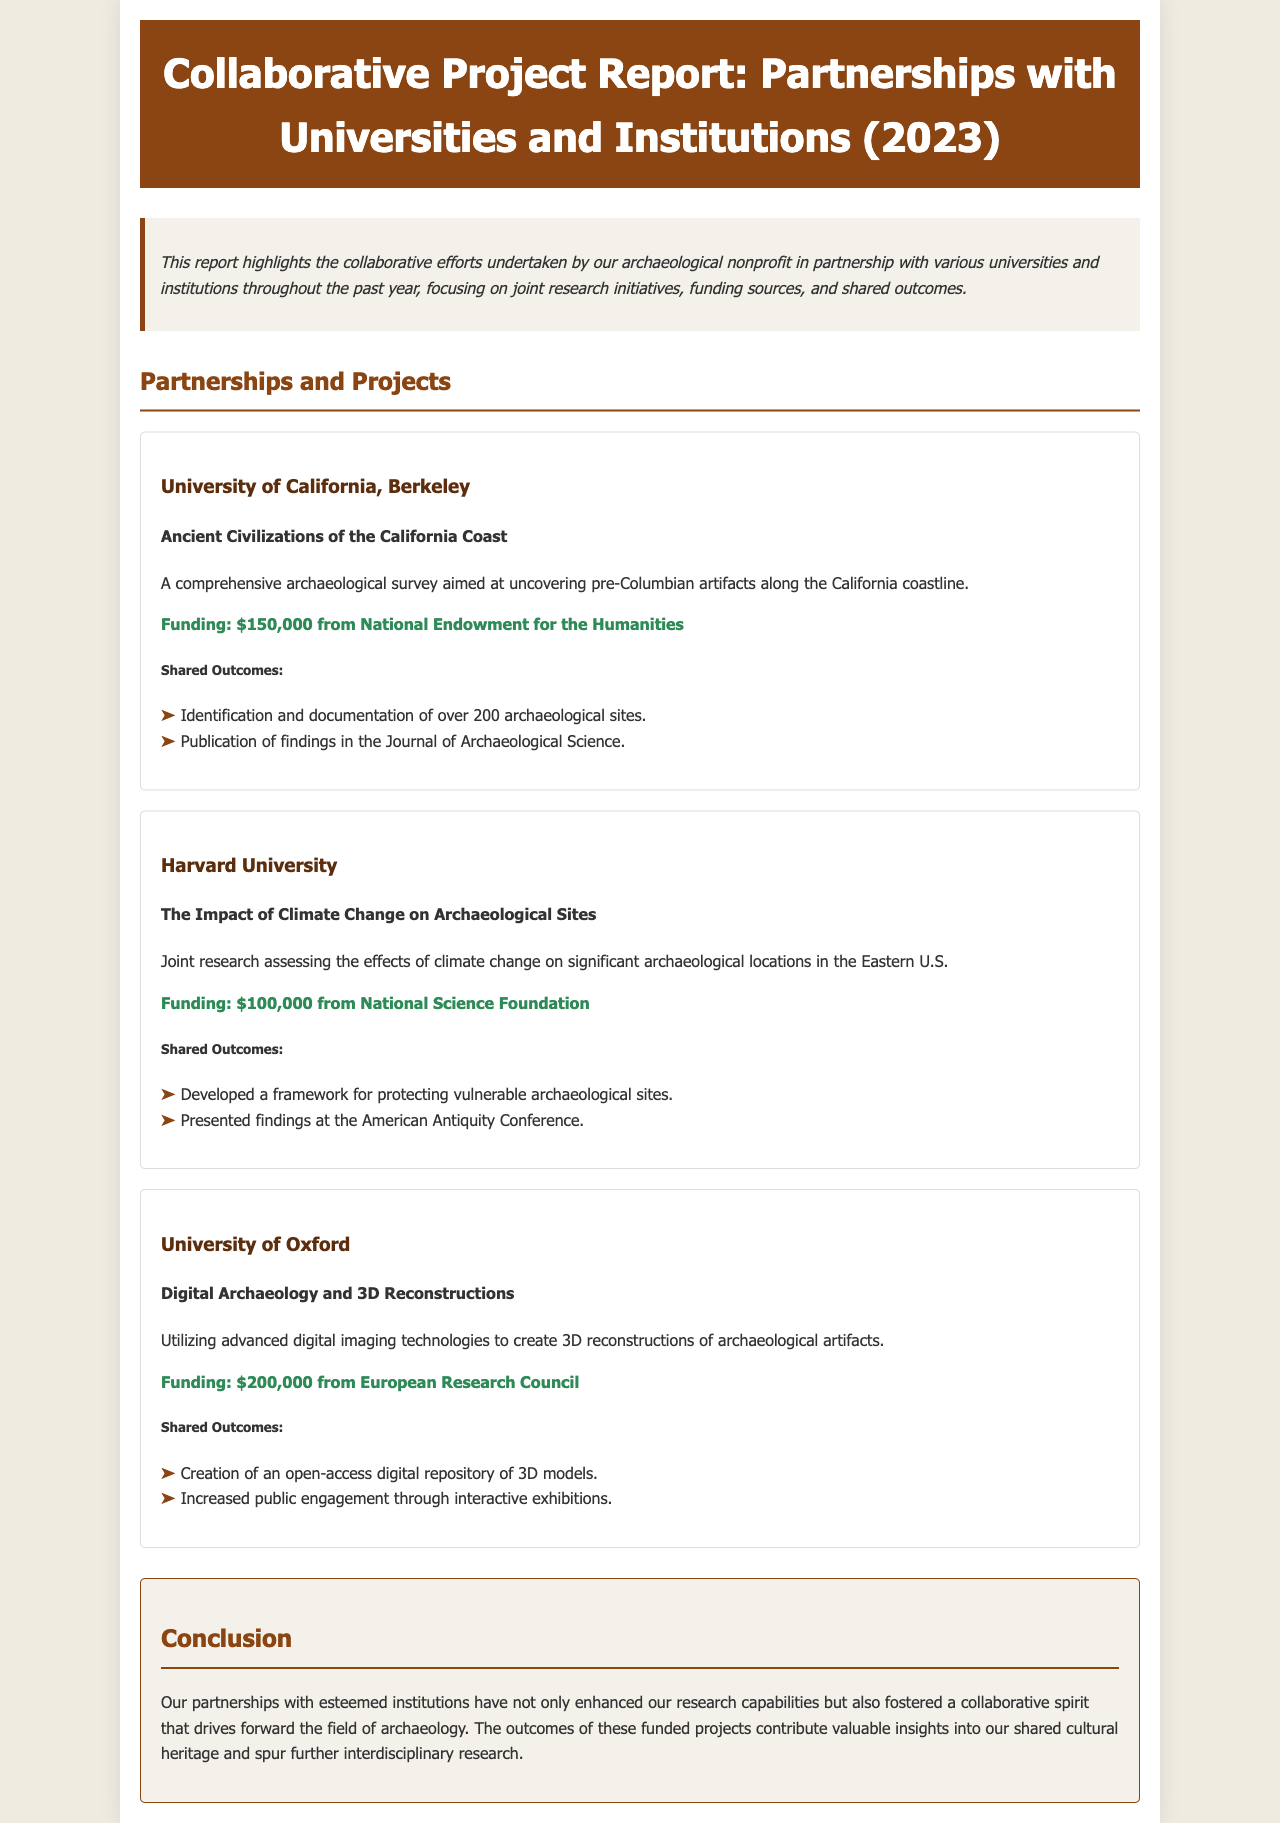What is the title of the report? The title of the report is explicitly stated in the header of the document.
Answer: Collaborative Project Report: Partnerships with Universities and Institutions (2023) How much funding was received from the National Endowment for the Humanities? The funding amount is specifically mentioned in the details of the partnership with the University of California, Berkeley.
Answer: $150,000 What research topic was covered in partnership with Harvard University? The topic is explicitly stated in the section describing the partnership, outlining the focus of the research.
Answer: The Impact of Climate Change on Archaeological Sites How many archaeological sites were documented in the UC Berkeley project? This information is found under the shared outcomes of the UC Berkeley partnership where specific outcomes are listed.
Answer: Over 200 Which university partnered on the Digital Archaeology and 3D Reconstructions project? The name of the university is highlighted in the partnership section dedicated to the specific project.
Answer: University of Oxford What was one of the shared outcomes of the Harvard University project? The outcomes are summarized in a list provided in the partnership description.
Answer: Developed a framework for protecting vulnerable archaeological sites What is the main purpose of the report? The purpose is outlined in the summary at the beginning of the document.
Answer: Highlight collaborative efforts in research How many distinct partnerships are mentioned in the report? The number of partnerships can be counted by looking at the section dedicated to partnerships and projects.
Answer: Three 